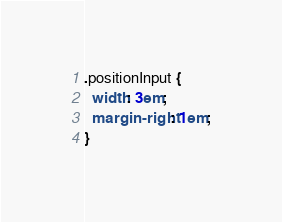<code> <loc_0><loc_0><loc_500><loc_500><_CSS_>
.positionInput {
  width: 3em;
  margin-right: 1em;
}
</code> 